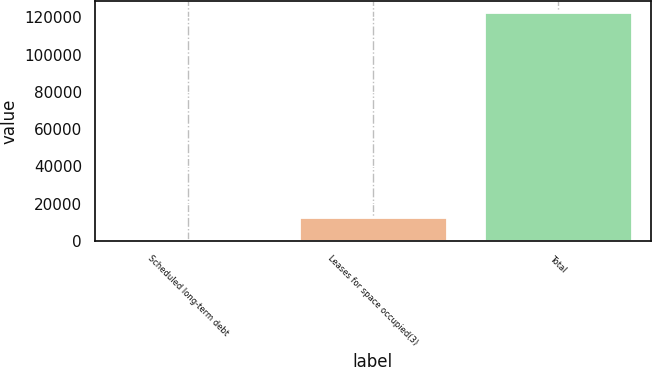<chart> <loc_0><loc_0><loc_500><loc_500><bar_chart><fcel>Scheduled long-term debt<fcel>Leases for space occupied(3)<fcel>Total<nl><fcel>519<fcel>12722.9<fcel>122558<nl></chart> 